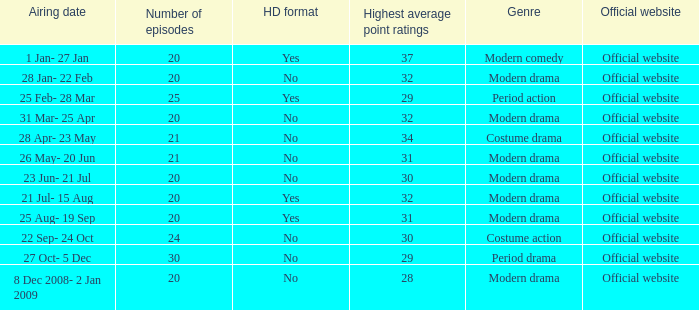What was the airing date when the number of episodes was larger than 20 and had the genre of costume action? 22 Sep- 24 Oct. 